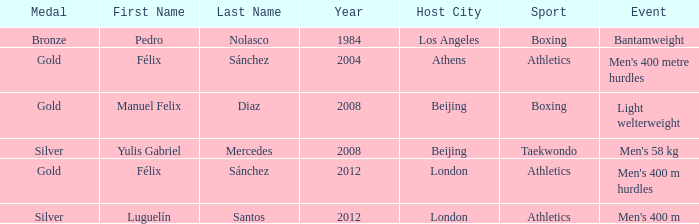Which Medal had a Name of félix sánchez, and a Games of 2012 london? Gold. 